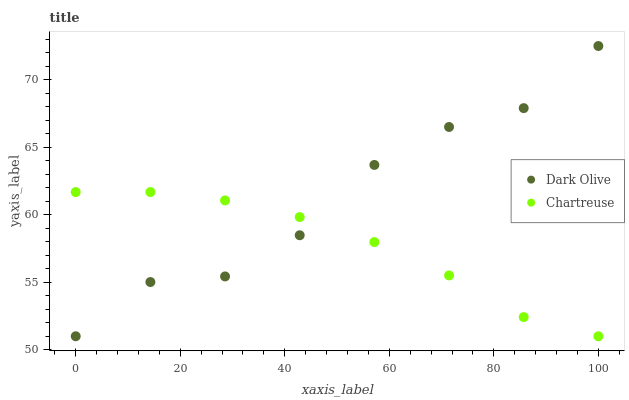Does Chartreuse have the minimum area under the curve?
Answer yes or no. Yes. Does Dark Olive have the maximum area under the curve?
Answer yes or no. Yes. Does Dark Olive have the minimum area under the curve?
Answer yes or no. No. Is Chartreuse the smoothest?
Answer yes or no. Yes. Is Dark Olive the roughest?
Answer yes or no. Yes. Is Dark Olive the smoothest?
Answer yes or no. No. Does Chartreuse have the lowest value?
Answer yes or no. Yes. Does Dark Olive have the highest value?
Answer yes or no. Yes. Does Chartreuse intersect Dark Olive?
Answer yes or no. Yes. Is Chartreuse less than Dark Olive?
Answer yes or no. No. Is Chartreuse greater than Dark Olive?
Answer yes or no. No. 